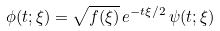<formula> <loc_0><loc_0><loc_500><loc_500>\phi ( t ; \xi ) = \sqrt { f ( \xi ) } \, e ^ { - t \xi / 2 } \, \psi ( t ; \xi )</formula> 